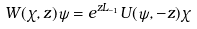<formula> <loc_0><loc_0><loc_500><loc_500>W ( \chi , z ) \psi = e ^ { z L _ { - 1 } } U ( \psi , - z ) \chi</formula> 